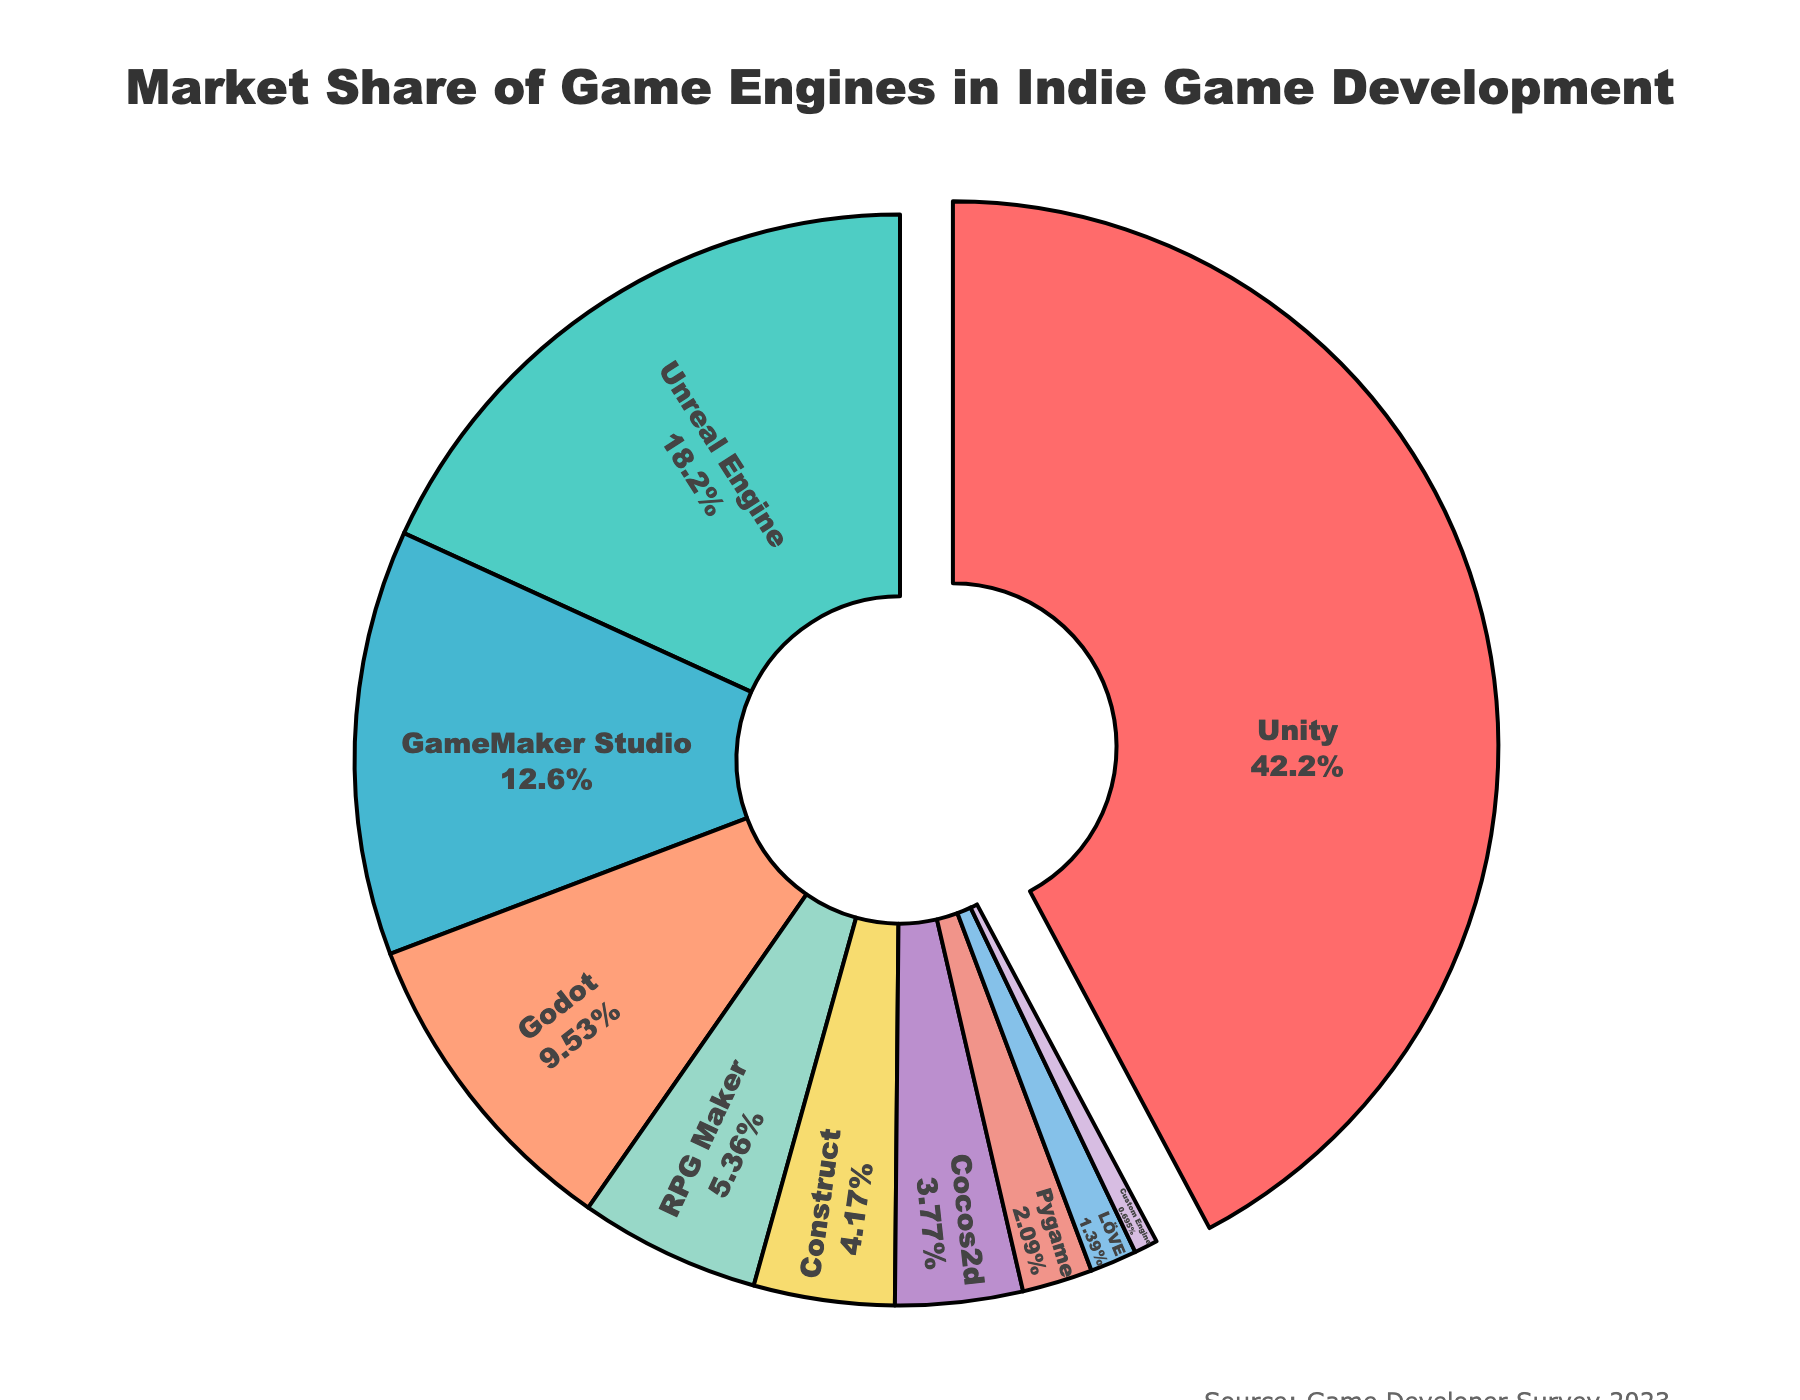Which game engine has the largest market share in indie game development? The pie chart shows different segments representing market shares of various game engines. The largest segment is the one labeled 'Unity'.
Answer: Unity What is the combined market share of Unity and Unreal Engine? Unity has a market share of 42.5% and Unreal Engine has 18.3%. Adding them together: 42.5 + 18.3 = 60.8%.
Answer: 60.8% Which two engines have the smallest market shares and what are their percentages? The smallest slices in the pie chart are labeled 'Custom Engine' and 'LÖVE'. Their percentages are 0.7% and 1.4%, respectively.
Answer: Custom Engine (0.7%) and LÖVE (1.4%) How much larger is the market share of Unity compared to RPG Maker? Unity has a market share of 42.5% and RPG Maker has 5.4%. The difference is 42.5 - 5.4 = 37.1%.
Answer: 37.1% What is the average market share of Godot, Pygame, and LÖVE? Sum the market shares of Godot (9.6%), Pygame (2.1%), and LÖVE (1.4%), then divide by the number of engines (3). (9.6 + 2.1 + 1.4) / 3 = 4.37%.
Answer: 4.37% Which engine is depicted with a blue-ish color and what is its market share? The pie chart segment with a blue-ish color is labeled 'Unreal Engine'. Its market share is 18.3%.
Answer: Unreal Engine (18.3%) Is the market share of GameMaker Studio larger or smaller than that of Godot, and by how much? GameMaker Studio's market share is 12.7%, and Godot's is 9.6%. The difference is 12.7 - 9.6 = 3.1%.
Answer: Larger by 3.1% What percentage of the market is not covered by Unity, Unreal Engine, and GameMaker Studio combined? First, combine the market shares of Unity (42.5%), Unreal Engine (18.3%), and GameMaker Studio (12.7%): 42.5 + 18.3 + 12.7 = 73.5%. Subtract this from 100%: 100 - 73.5 = 26.5%.
Answer: 26.5% What is the total market share of engines other than Unity, Unreal Engine, and GameMaker Studio? Sum the market shares of all engines excluding Unity (42.5%), Unreal Engine (18.3%), and GameMaker Studio (12.7%): 100% - 73.5% = 26.5%.
Answer: 26.5% How much greater is the market share of Unity compared to Custom Engine and Cocos2d combined? Custom Engine has 0.7% and Cocos2d has 3.8%. Combined: 0.7 + 3.8 = 4.5%. Difference: 42.5 - 4.5 = 38%.
Answer: 38% 